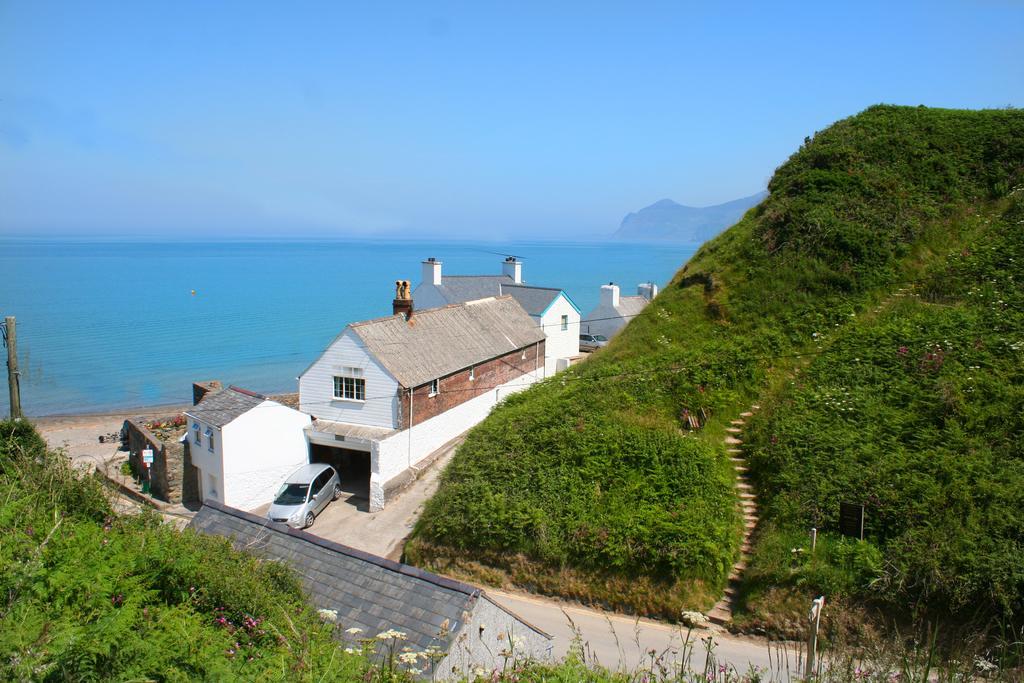Could you give a brief overview of what you see in this image? In this image we can see houses, road and mountains covered with plants. Background of the image sea is there. Top of the image sky is present. 